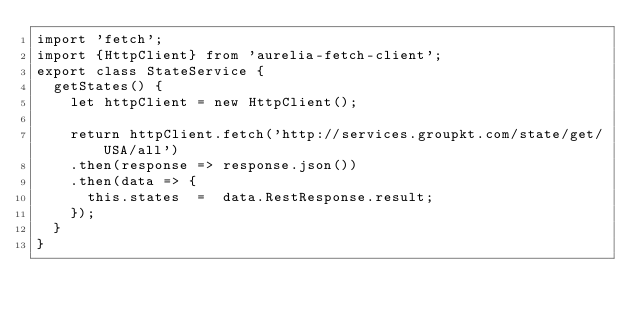Convert code to text. <code><loc_0><loc_0><loc_500><loc_500><_JavaScript_>import 'fetch';
import {HttpClient} from 'aurelia-fetch-client';
export class StateService {
  getStates() {
    let httpClient = new HttpClient();

    return httpClient.fetch('http://services.groupkt.com/state/get/USA/all')
    .then(response => response.json())
    .then(data => {
      this.states  =  data.RestResponse.result;
    });
  }
}
</code> 